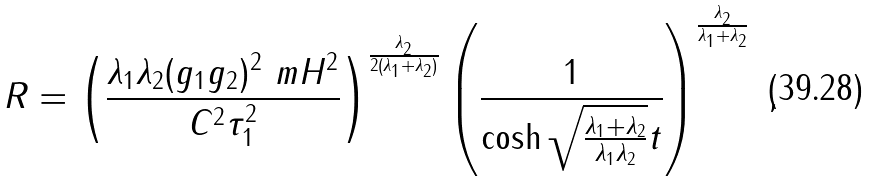<formula> <loc_0><loc_0><loc_500><loc_500>R = \left ( \frac { \lambda _ { 1 } \lambda _ { 2 } ( g _ { 1 } g _ { 2 } ) ^ { 2 } \ m H ^ { 2 } } { C ^ { 2 } \tau _ { 1 } ^ { 2 } } \right ) ^ { \frac { \lambda _ { 2 } } { 2 ( \lambda _ { 1 } + \lambda _ { 2 } ) } } \left ( \frac { 1 } { \cosh \sqrt { \frac { \lambda _ { 1 } + \lambda _ { 2 } } { \lambda _ { 1 } \lambda _ { 2 } } } t } \right ) ^ { \frac { \lambda _ { 2 } } { \lambda _ { 1 } + \lambda _ { 2 } } } \ ,</formula> 